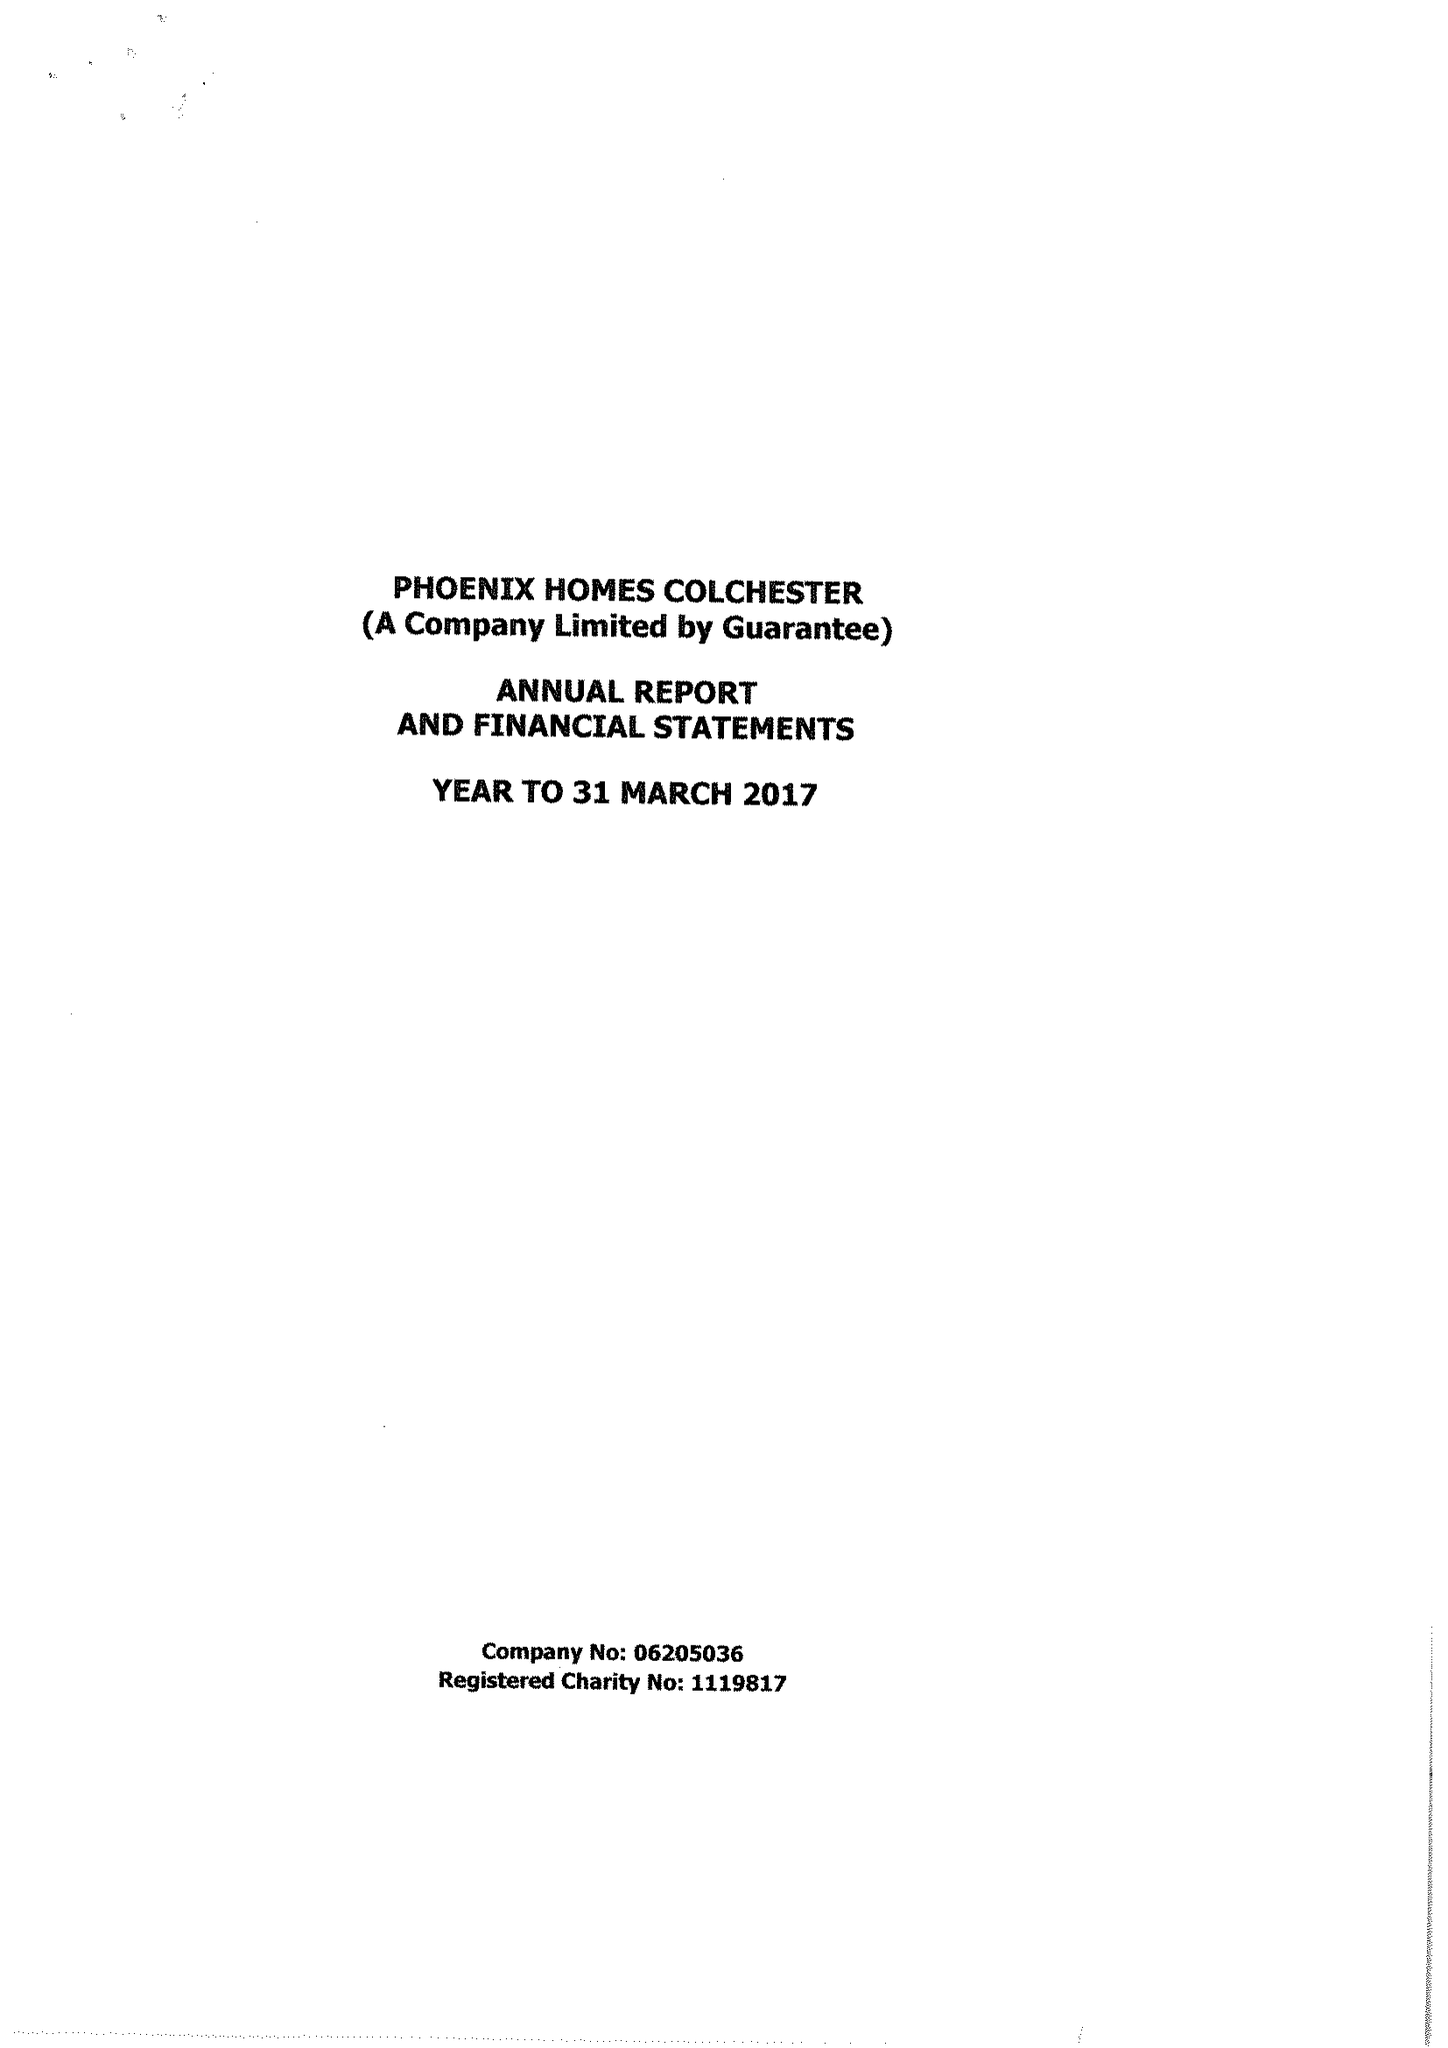What is the value for the charity_number?
Answer the question using a single word or phrase. 1119817 